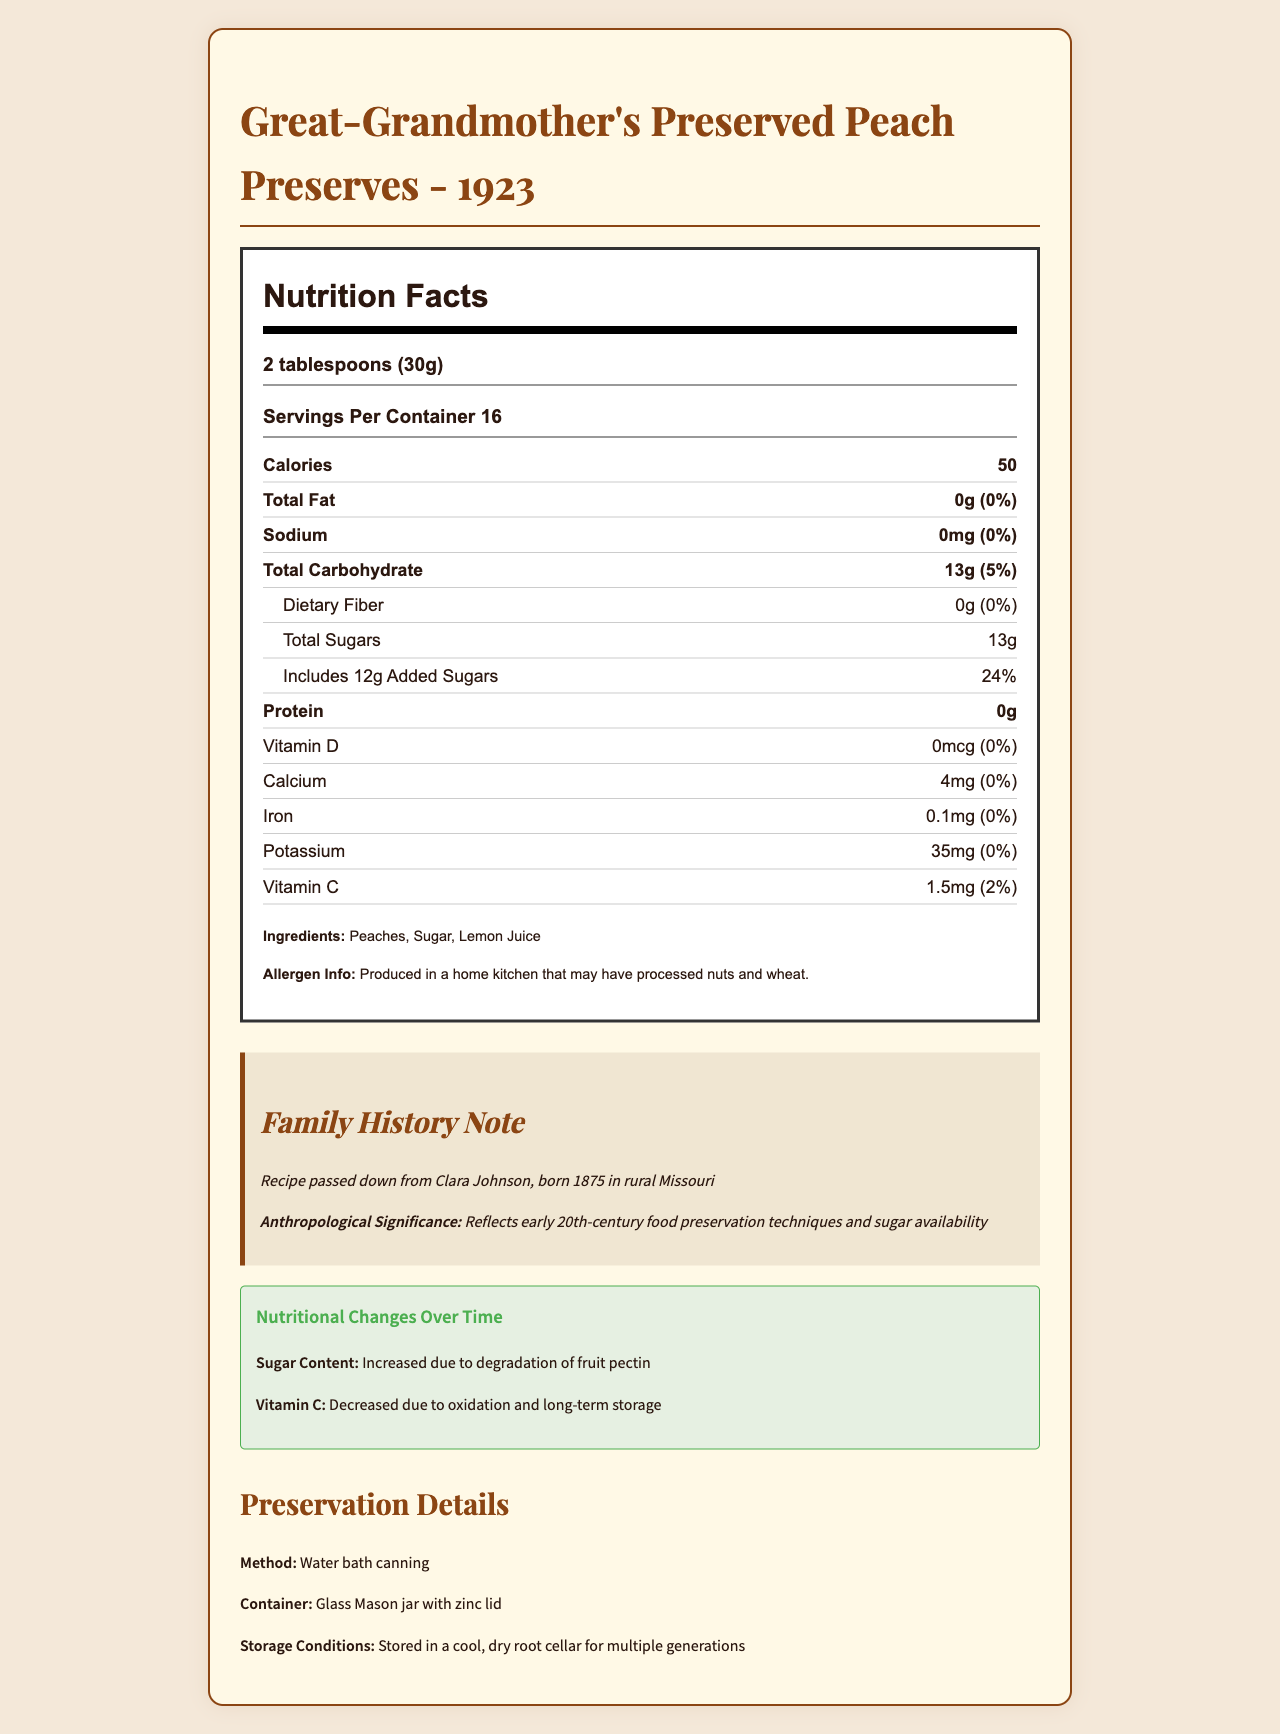what is the total fiber content per serving? The document states that the dietary fiber content is 0 grams.
Answer: 0 grams How many calories are in one serving of the preserved peach preserves? The document specifies that one serving contains 50 calories.
Answer: 50 calories What preservation method was used for the peach preserves? The document mentions that the peach preserves were preserved using the water bath canning method.
Answer: Water bath canning What is the main ingredient of Great-Grandmother's Preserved Peach Preserves - 1923? The ingredients list shows that peaches are the first ingredient.
Answer: Peaches How much vitamin C is in one serving of the preserved peach preserves? The document lists the vitamin C content as 1.5 mg per serving.
Answer: 1.5 mg What is the daily value percentage of total sugars per serving? The document indicates that total sugars, including added sugars, account for 24% of the daily value.
Answer: 24% By how much has the vitamin C content changed over time? The nutritional changes section states that vitamin C decreased from 2 mg to 1.5 mg.
Answer: Decreased by 0.5 mg Which of the following is a reason for the change in sugar content over time? A. Change in recipes B. Degradation of fruit pectin C. Reduction in sugar availability The document states that the increase in sugar content is due to the degradation of fruit pectin.
Answer: B What family member passed down the peach preserves recipe? A. Clara Johnson B. Sarah Johnson C. Elizabeth Johnson The family history note mentions the recipe was passed down from Clara Johnson.
Answer: A Is there any allergen information provided? The document indicates that the product was produced in a home kitchen that may have processed nuts and wheat.
Answer: Yes Summarize the overall nutritional information provided for Great-Grandmother's Preserved Peach Preserves - 1923. The nutritional facts section provides these details about the content in each serving, including macro and micronutrients along with their daily value percentages.
Answer: The preserved peach preserves have 50 calories per serving, with no fat, sodium, dietary fiber, or protein. They contain 13 grams of total carbohydrates, including 12 grams of added sugars, and trace amounts of vitamin C, calcium, iron, and potassium. What color is the label background on the nutrition facts section? The visual background color of the label cannot be determined from the document's text-only description.
Answer: Cannot be determined 